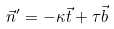<formula> <loc_0><loc_0><loc_500><loc_500>\vec { n } ^ { \prime } = - \kappa \vec { t } + { \tau } \vec { b }</formula> 